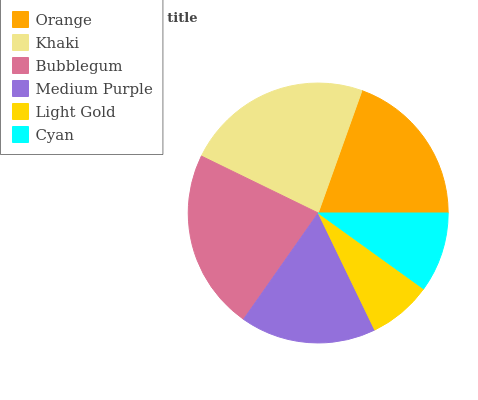Is Light Gold the minimum?
Answer yes or no. Yes. Is Khaki the maximum?
Answer yes or no. Yes. Is Bubblegum the minimum?
Answer yes or no. No. Is Bubblegum the maximum?
Answer yes or no. No. Is Khaki greater than Bubblegum?
Answer yes or no. Yes. Is Bubblegum less than Khaki?
Answer yes or no. Yes. Is Bubblegum greater than Khaki?
Answer yes or no. No. Is Khaki less than Bubblegum?
Answer yes or no. No. Is Orange the high median?
Answer yes or no. Yes. Is Medium Purple the low median?
Answer yes or no. Yes. Is Medium Purple the high median?
Answer yes or no. No. Is Light Gold the low median?
Answer yes or no. No. 